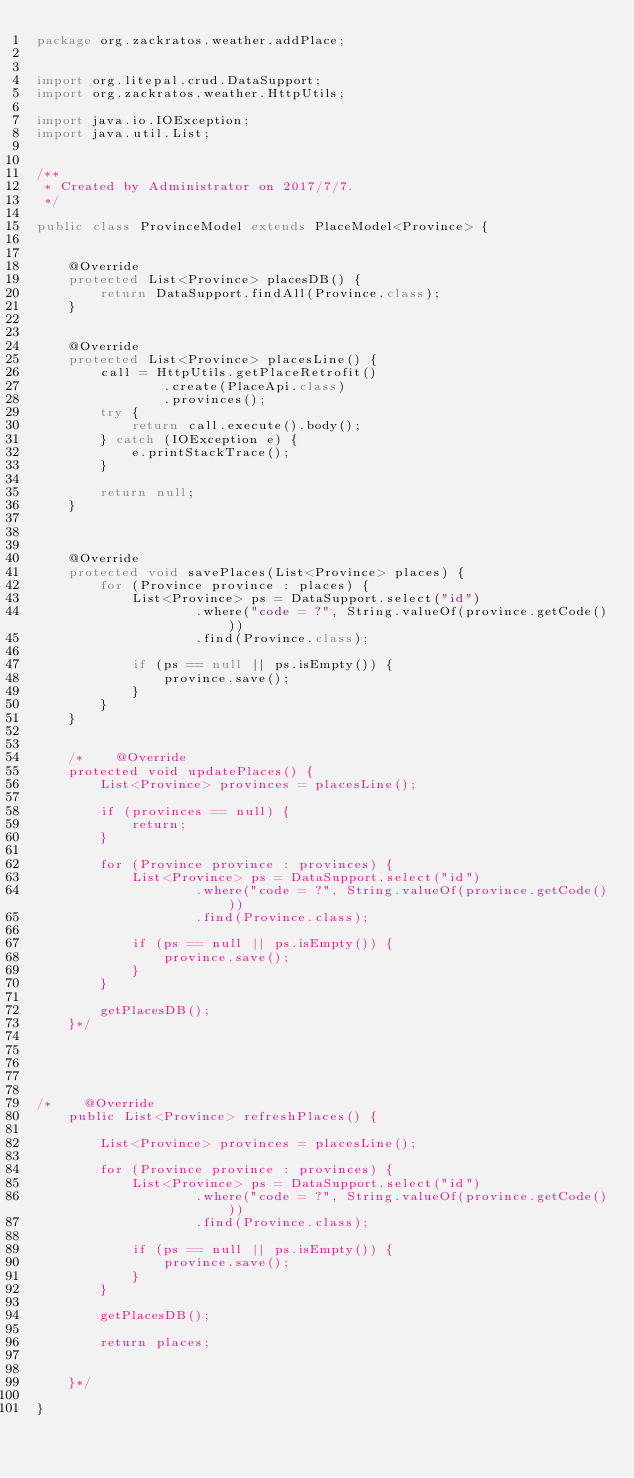Convert code to text. <code><loc_0><loc_0><loc_500><loc_500><_Java_>package org.zackratos.weather.addPlace;


import org.litepal.crud.DataSupport;
import org.zackratos.weather.HttpUtils;

import java.io.IOException;
import java.util.List;


/**
 * Created by Administrator on 2017/7/7.
 */

public class ProvinceModel extends PlaceModel<Province> {


    @Override
    protected List<Province> placesDB() {
        return DataSupport.findAll(Province.class);
    }


    @Override
    protected List<Province> placesLine() {
        call = HttpUtils.getPlaceRetrofit()
                .create(PlaceApi.class)
                .provinces();
        try {
            return call.execute().body();
        } catch (IOException e) {
            e.printStackTrace();
        }

        return null;
    }



    @Override
    protected void savePlaces(List<Province> places) {
        for (Province province : places) {
            List<Province> ps = DataSupport.select("id")
                    .where("code = ?", String.valueOf(province.getCode()))
                    .find(Province.class);

            if (ps == null || ps.isEmpty()) {
                province.save();
            }
        }
    }


    /*    @Override
    protected void updatePlaces() {
        List<Province> provinces = placesLine();

        if (provinces == null) {
            return;
        }

        for (Province province : provinces) {
            List<Province> ps = DataSupport.select("id")
                    .where("code = ?", String.valueOf(province.getCode()))
                    .find(Province.class);

            if (ps == null || ps.isEmpty()) {
                province.save();
            }
        }

        getPlacesDB();
    }*/





/*    @Override
    public List<Province> refreshPlaces() {

        List<Province> provinces = placesLine();

        for (Province province : provinces) {
            List<Province> ps = DataSupport.select("id")
                    .where("code = ?", String.valueOf(province.getCode()))
                    .find(Province.class);

            if (ps == null || ps.isEmpty()) {
                province.save();
            }
        }

        getPlacesDB();

        return places;


    }*/

}
</code> 